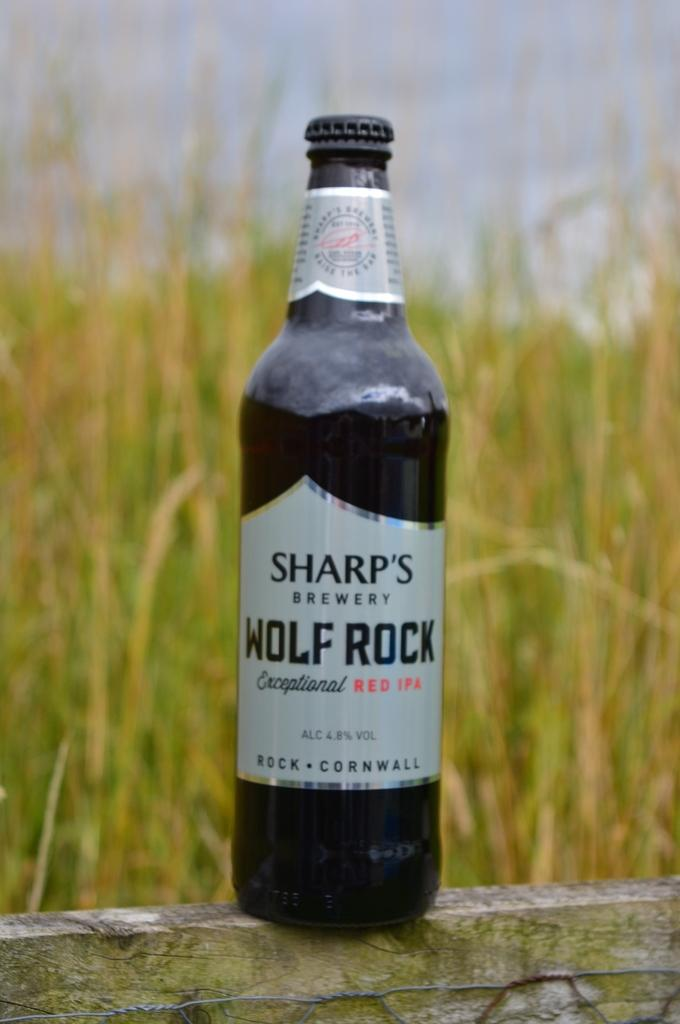<image>
Share a concise interpretation of the image provided. A bottle of Sharp's Wolf Rock beer with a field in the background. 